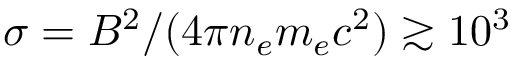Convert formula to latex. <formula><loc_0><loc_0><loc_500><loc_500>\sigma = B ^ { 2 } / ( 4 \pi n _ { e } m _ { e } c ^ { 2 } ) \gtrsim 1 0 ^ { 3 }</formula> 